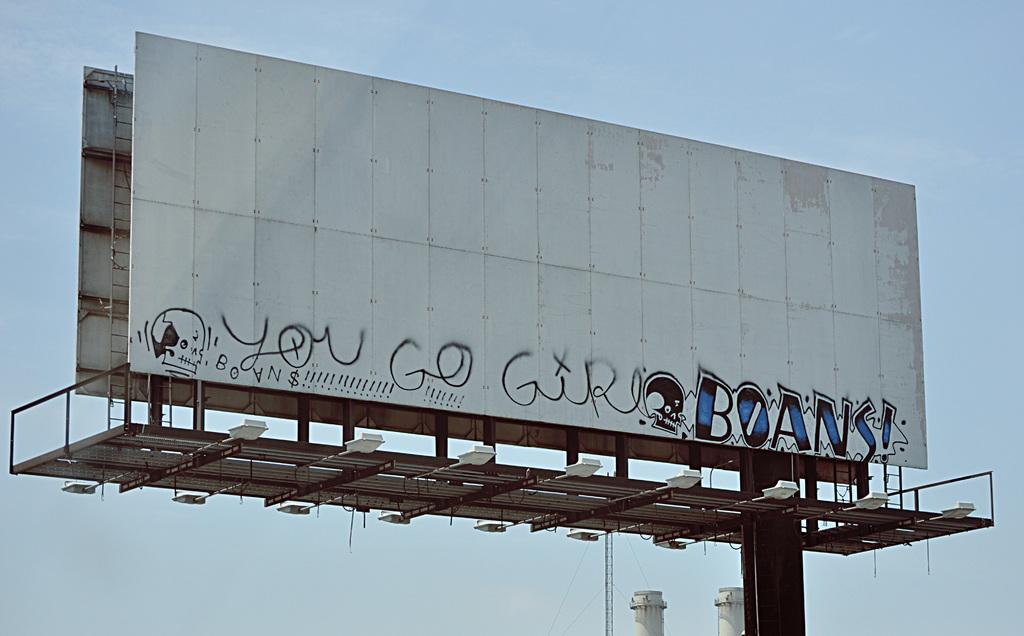<image>
Offer a succinct explanation of the picture presented. Someone has painted "you go girl" on an empty billboard. 